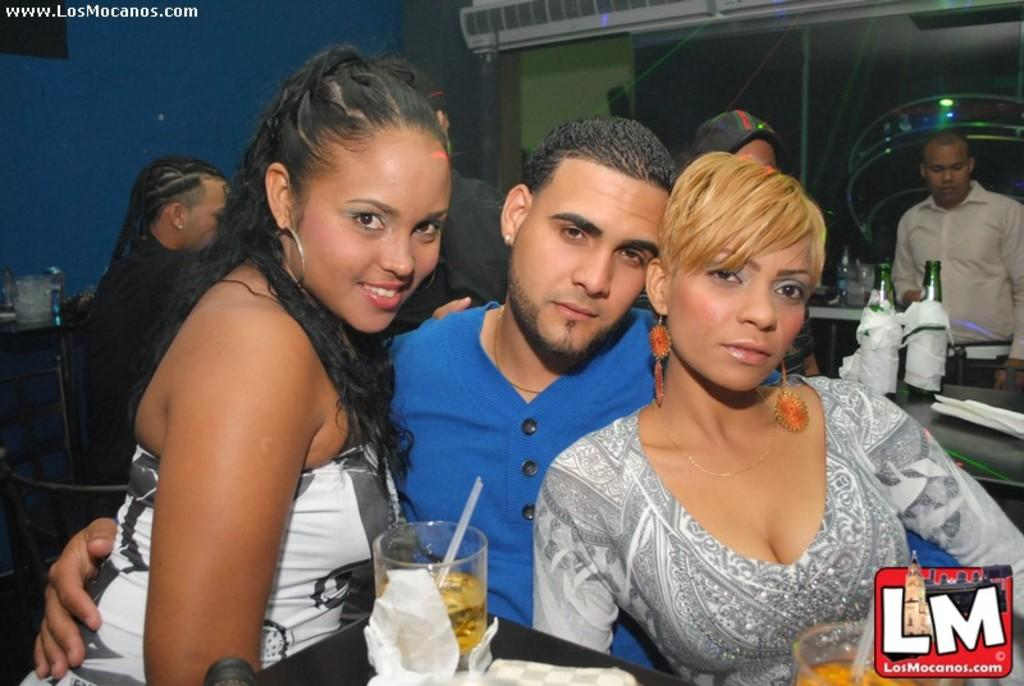How many persons are highlighted in the image? There are three highlighted persons in the image. What are the other persons doing in the image? Other persons are sitting on chairs. What objects are on the tablet in the image? There is a glass and bottles on the tablet. What is the color of the wall in the image? The wall has a blue color. What type of paint is being used by the person in the image? There is no indication in the image that anyone is using paint, as the focus is on the highlighted persons and the objects on the tablet. 